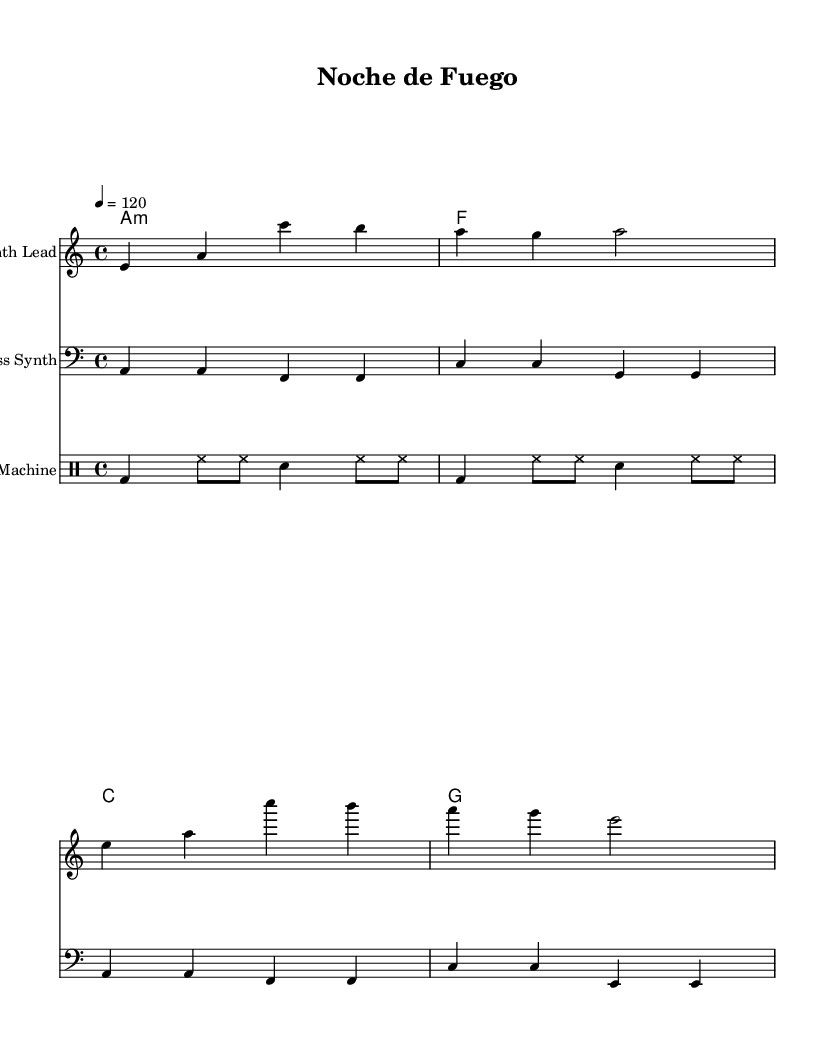What is the key signature of this music? The key signature is A minor, indicated by the absence of any sharps or flats in the score. A minor is the relative minor of C major, which has no accidentals.
Answer: A minor What is the time signature of this music? The time signature is 4/4, which is indicated at the beginning of the score. It signifies that there are four beats in each measure, and the quarter note receives one beat.
Answer: 4/4 What is the tempo marking of this piece? The tempo marking is indicated as "4 = 120", meaning that there are 120 beats per minute with a quarter note receiving one beat.
Answer: 120 What is the first chord in the harmony section? The first chord in the harmony section is A minor, indicated as "a1:m". This chord is played in the bass for the entirety of the piece and sets the tonal foundation.
Answer: A minor How many measures are there in the melody section? The melody section has four measures. Each measure is separated by vertical lines and contains a combination of quarter and half notes, totaling four measures.
Answer: 4 How does the bass line interact rhythmically with the drum pattern? The bass line and drum pattern both exhibit a strong rhythmic drive. The bass line aligns with the kick drum, which strikes on the strong beats, providing a solid foundation for the groove, while the hi-hat plays a consistent eighth-note rhythm to keep the energy lively.
Answer: Strong rhythmic drive What type of instrument is indicated for the melody? The melody is to be performed on a "Synth Lead", as indicated in the score. This aligns with the synth-pop genre, known for its prominent use of synthesizers in leading melodic roles.
Answer: Synth Lead 